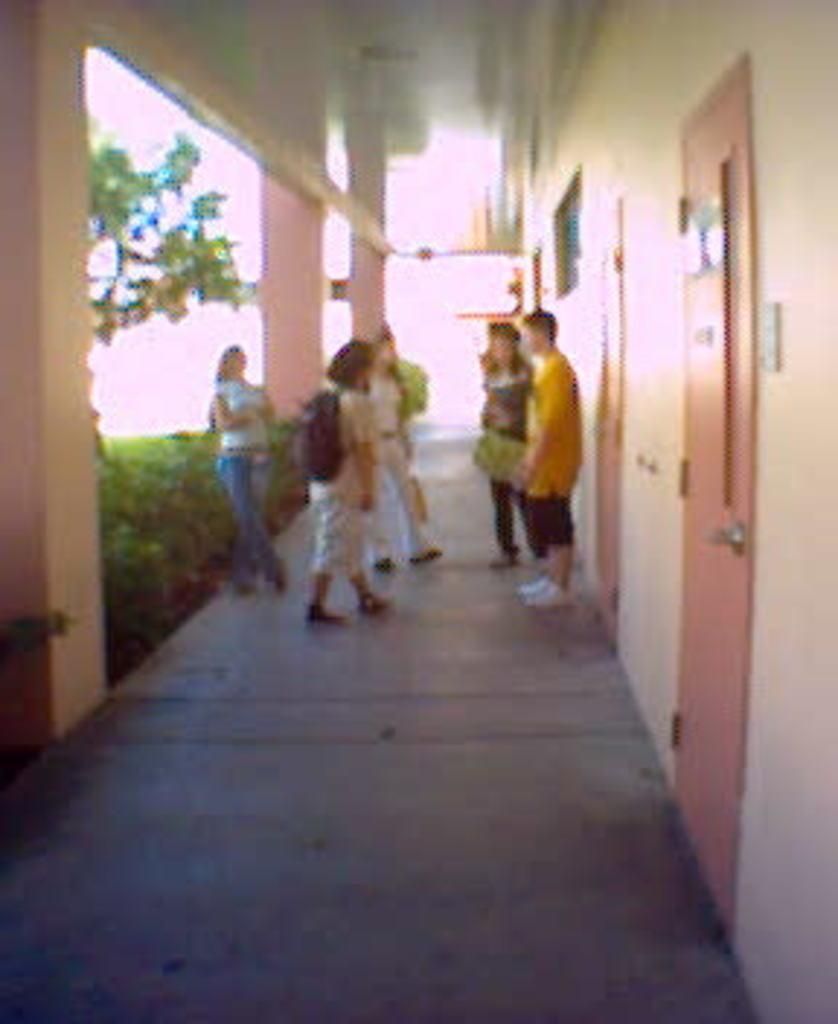In one or two sentences, can you explain what this image depicts? In the picture we can see a few people are standing in the corridor beside them, we can see the wall with doors and on the other side we can see the pillars and the plants. 